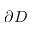<formula> <loc_0><loc_0><loc_500><loc_500>\partial D</formula> 